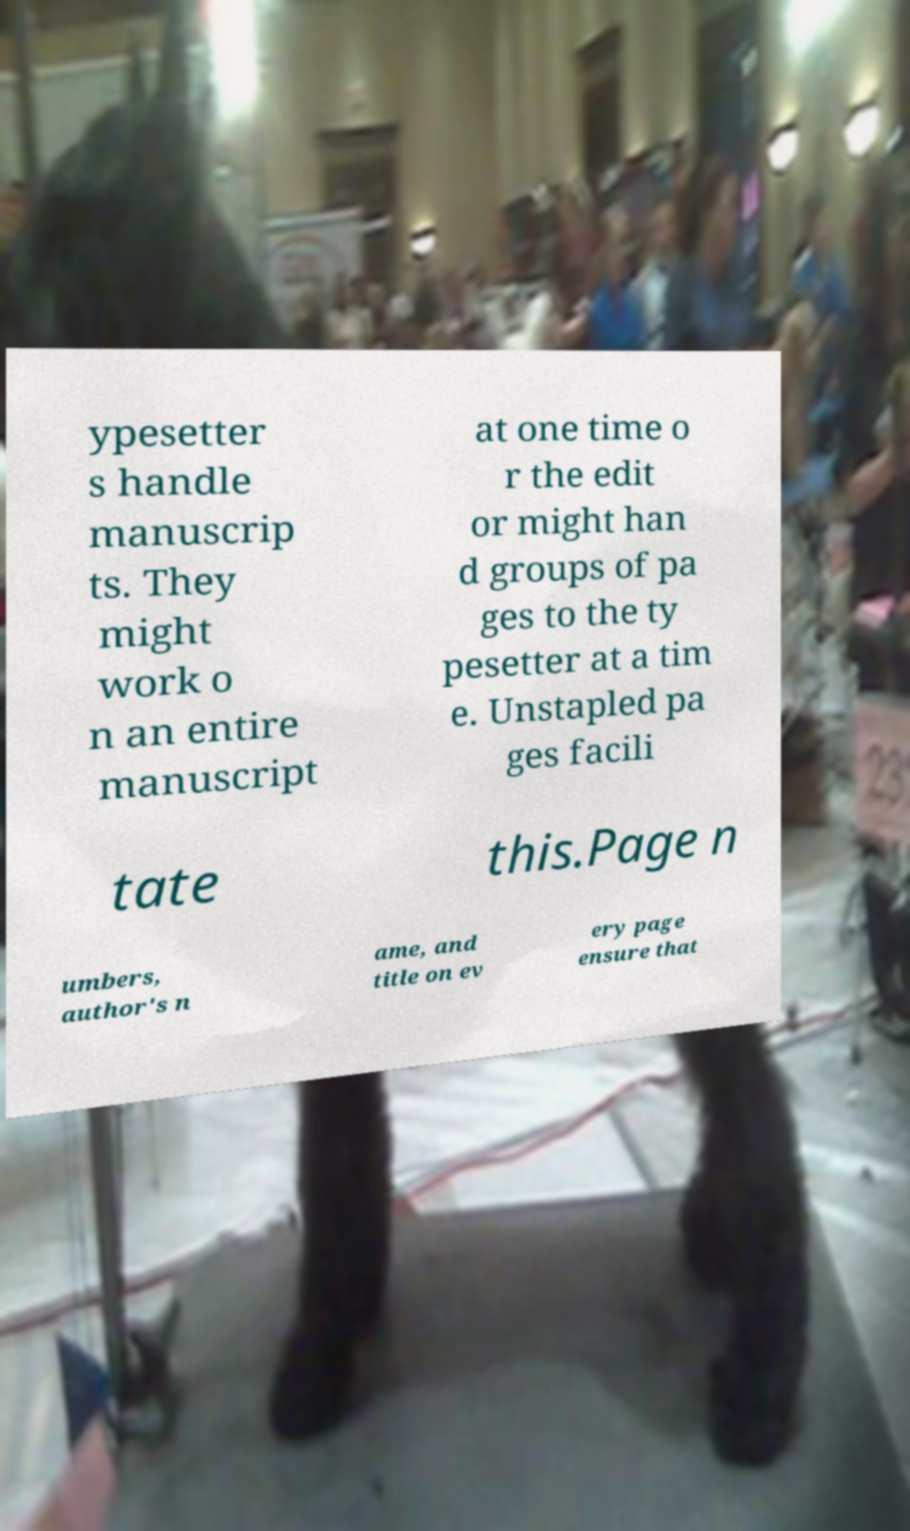There's text embedded in this image that I need extracted. Can you transcribe it verbatim? ypesetter s handle manuscrip ts. They might work o n an entire manuscript at one time o r the edit or might han d groups of pa ges to the ty pesetter at a tim e. Unstapled pa ges facili tate this.Page n umbers, author's n ame, and title on ev ery page ensure that 